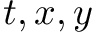Convert formula to latex. <formula><loc_0><loc_0><loc_500><loc_500>t , x , y</formula> 